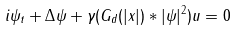<formula> <loc_0><loc_0><loc_500><loc_500>i \psi _ { t } + \Delta \psi + \gamma ( G _ { d } ( | x | ) * | \psi | ^ { 2 } ) u = 0</formula> 